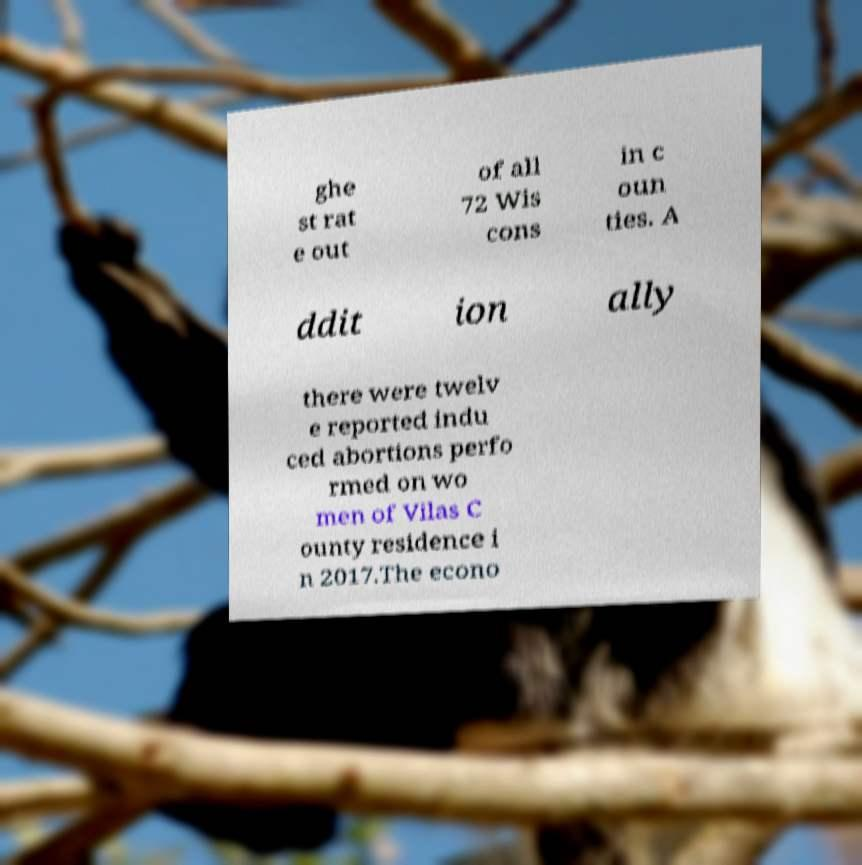Could you assist in decoding the text presented in this image and type it out clearly? ghe st rat e out of all 72 Wis cons in c oun ties. A ddit ion ally there were twelv e reported indu ced abortions perfo rmed on wo men of Vilas C ounty residence i n 2017.The econo 